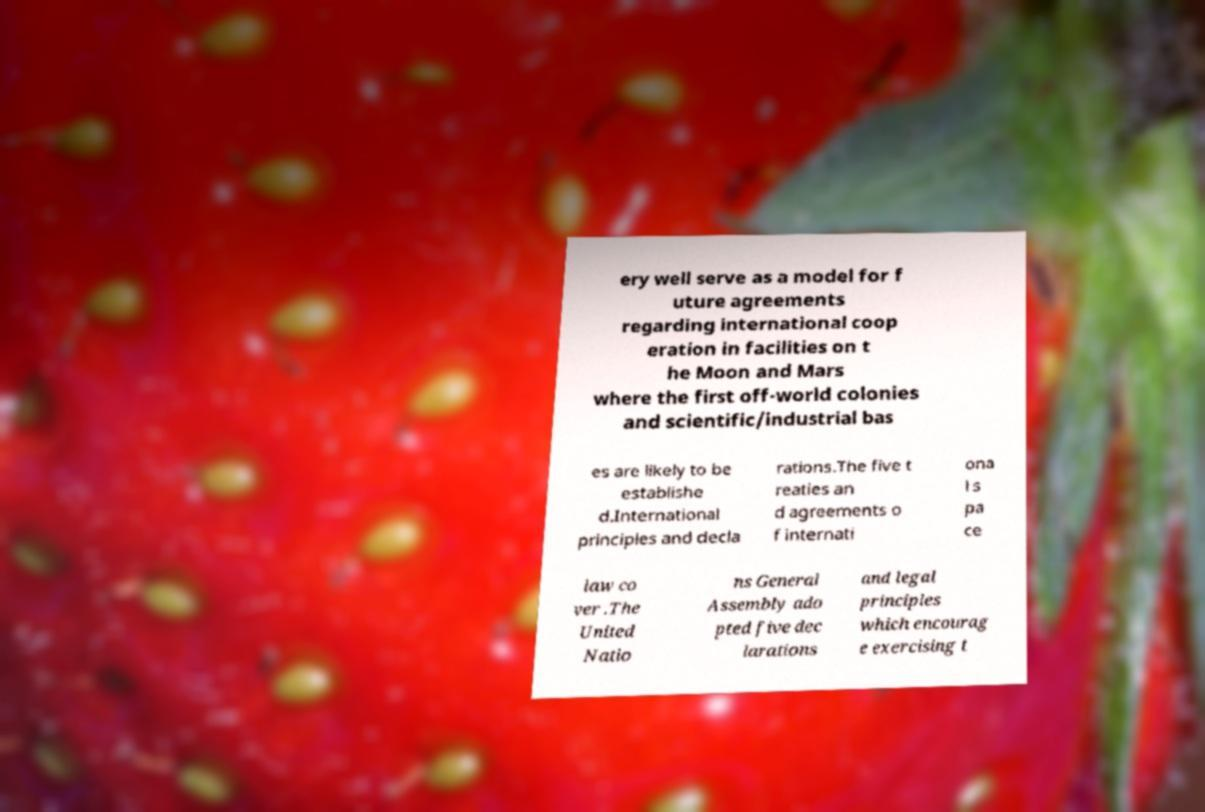For documentation purposes, I need the text within this image transcribed. Could you provide that? ery well serve as a model for f uture agreements regarding international coop eration in facilities on t he Moon and Mars where the first off-world colonies and scientific/industrial bas es are likely to be establishe d.International principles and decla rations.The five t reaties an d agreements o f internati ona l s pa ce law co ver .The United Natio ns General Assembly ado pted five dec larations and legal principles which encourag e exercising t 